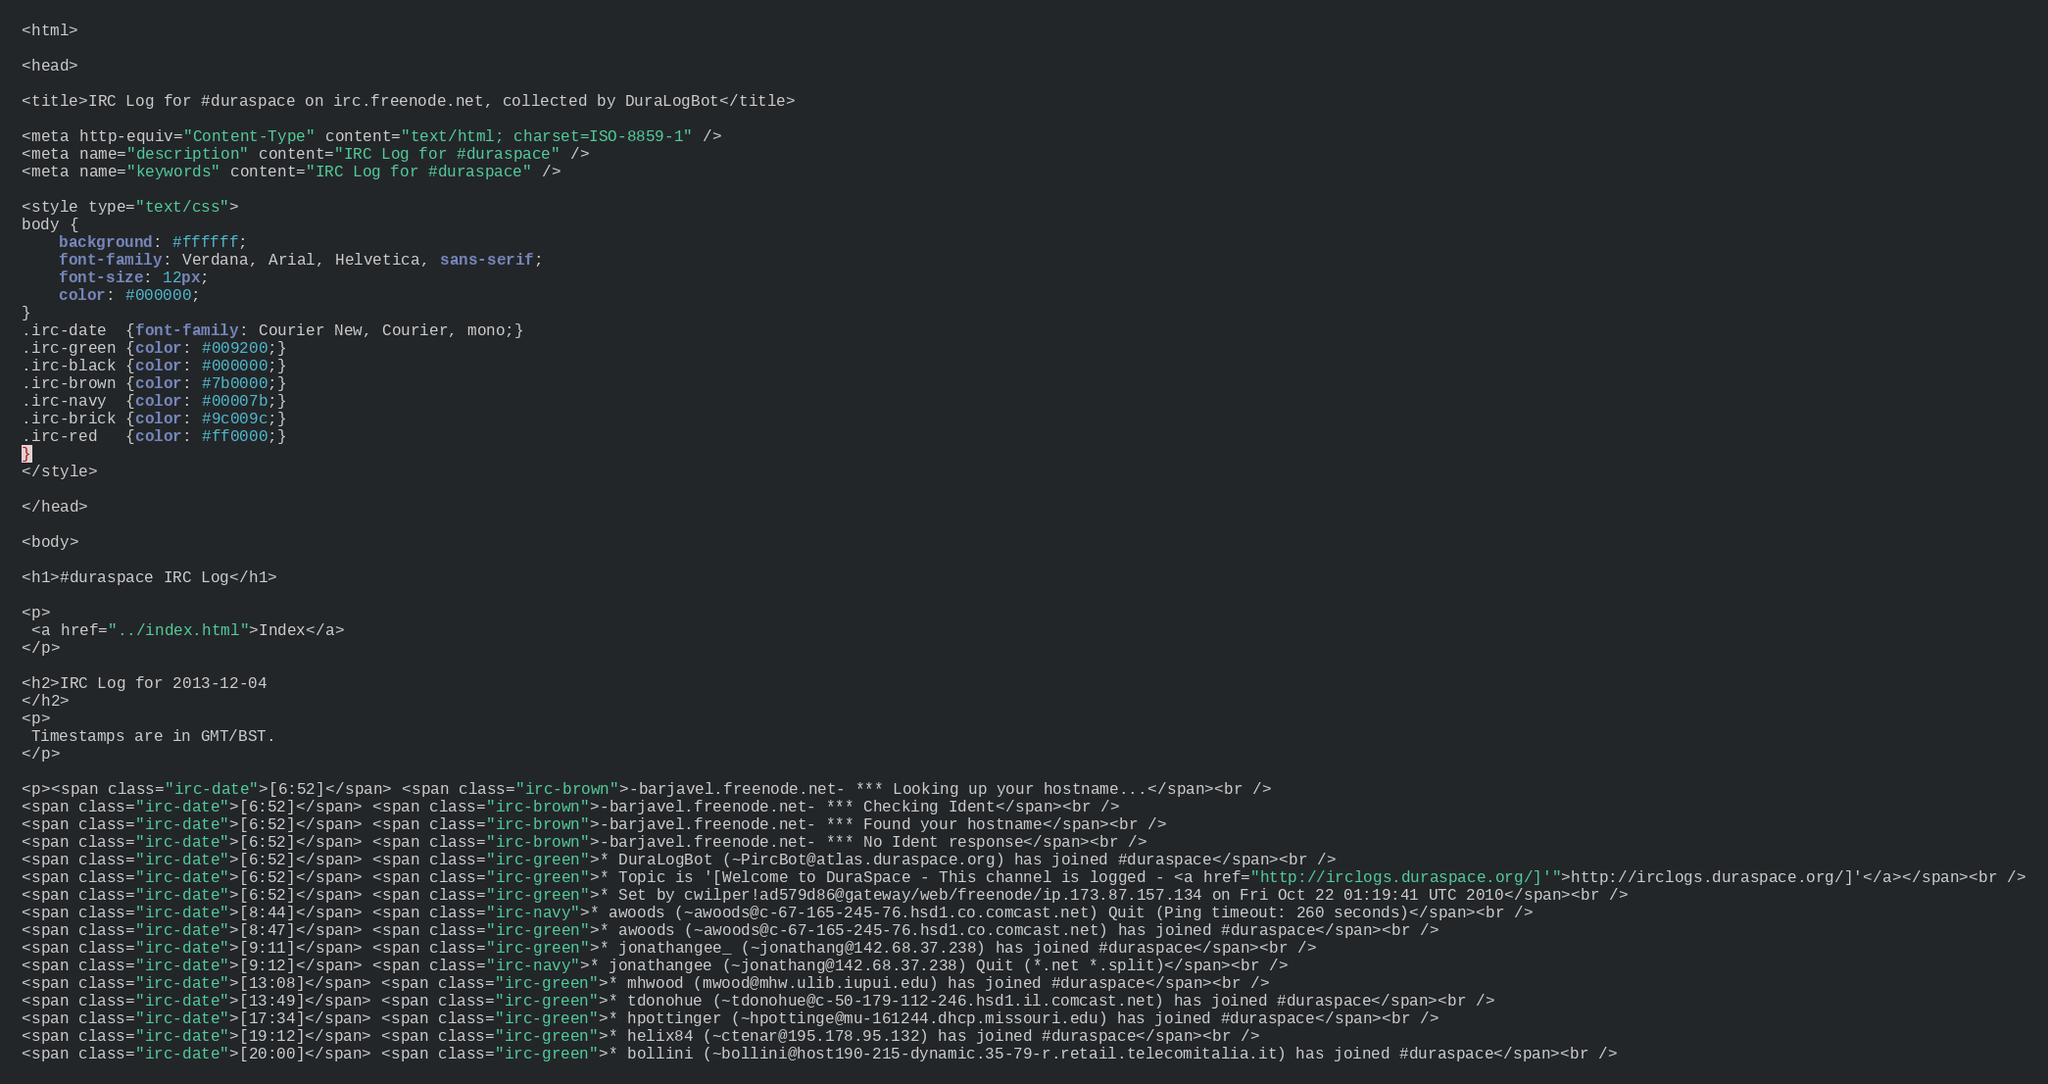<code> <loc_0><loc_0><loc_500><loc_500><_HTML_><html>

<head>

<title>IRC Log for #duraspace on irc.freenode.net, collected by DuraLogBot</title>

<meta http-equiv="Content-Type" content="text/html; charset=ISO-8859-1" />
<meta name="description" content="IRC Log for #duraspace" />
<meta name="keywords" content="IRC Log for #duraspace" />

<style type="text/css">
body {
    background: #ffffff;
    font-family: Verdana, Arial, Helvetica, sans-serif;
    font-size: 12px;
    color: #000000;
}
.irc-date  {font-family: Courier New, Courier, mono;}
.irc-green {color: #009200;}
.irc-black {color: #000000;}
.irc-brown {color: #7b0000;}
.irc-navy  {color: #00007b;}
.irc-brick {color: #9c009c;}
.irc-red   {color: #ff0000;}
}
</style>

</head>

<body>

<h1>#duraspace IRC Log</h1>

<p>
 <a href="../index.html">Index</a>
</p>

<h2>IRC Log for 2013-12-04
</h2>
<p>
 Timestamps are in GMT/BST.
</p>

<p><span class="irc-date">[6:52]</span> <span class="irc-brown">-barjavel.freenode.net- *** Looking up your hostname...</span><br />
<span class="irc-date">[6:52]</span> <span class="irc-brown">-barjavel.freenode.net- *** Checking Ident</span><br />
<span class="irc-date">[6:52]</span> <span class="irc-brown">-barjavel.freenode.net- *** Found your hostname</span><br />
<span class="irc-date">[6:52]</span> <span class="irc-brown">-barjavel.freenode.net- *** No Ident response</span><br />
<span class="irc-date">[6:52]</span> <span class="irc-green">* DuraLogBot (~PircBot@atlas.duraspace.org) has joined #duraspace</span><br />
<span class="irc-date">[6:52]</span> <span class="irc-green">* Topic is '[Welcome to DuraSpace - This channel is logged - <a href="http://irclogs.duraspace.org/]'">http://irclogs.duraspace.org/]'</a></span><br />
<span class="irc-date">[6:52]</span> <span class="irc-green">* Set by cwilper!ad579d86@gateway/web/freenode/ip.173.87.157.134 on Fri Oct 22 01:19:41 UTC 2010</span><br />
<span class="irc-date">[8:44]</span> <span class="irc-navy">* awoods (~awoods@c-67-165-245-76.hsd1.co.comcast.net) Quit (Ping timeout: 260 seconds)</span><br />
<span class="irc-date">[8:47]</span> <span class="irc-green">* awoods (~awoods@c-67-165-245-76.hsd1.co.comcast.net) has joined #duraspace</span><br />
<span class="irc-date">[9:11]</span> <span class="irc-green">* jonathangee_ (~jonathang@142.68.37.238) has joined #duraspace</span><br />
<span class="irc-date">[9:12]</span> <span class="irc-navy">* jonathangee (~jonathang@142.68.37.238) Quit (*.net *.split)</span><br />
<span class="irc-date">[13:08]</span> <span class="irc-green">* mhwood (mwood@mhw.ulib.iupui.edu) has joined #duraspace</span><br />
<span class="irc-date">[13:49]</span> <span class="irc-green">* tdonohue (~tdonohue@c-50-179-112-246.hsd1.il.comcast.net) has joined #duraspace</span><br />
<span class="irc-date">[17:34]</span> <span class="irc-green">* hpottinger (~hpottinge@mu-161244.dhcp.missouri.edu) has joined #duraspace</span><br />
<span class="irc-date">[19:12]</span> <span class="irc-green">* helix84 (~ctenar@195.178.95.132) has joined #duraspace</span><br />
<span class="irc-date">[20:00]</span> <span class="irc-green">* bollini (~bollini@host190-215-dynamic.35-79-r.retail.telecomitalia.it) has joined #duraspace</span><br /></code> 